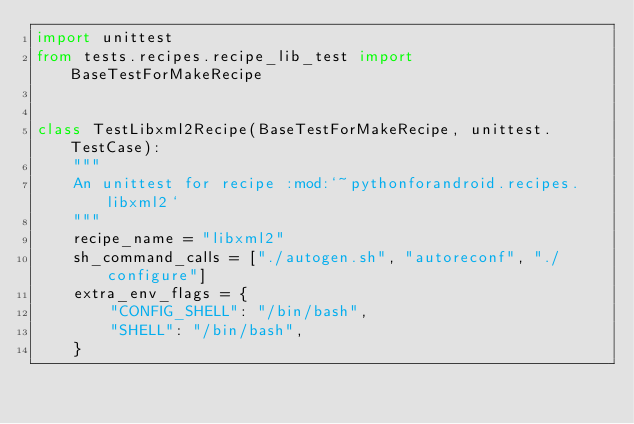<code> <loc_0><loc_0><loc_500><loc_500><_Python_>import unittest
from tests.recipes.recipe_lib_test import BaseTestForMakeRecipe


class TestLibxml2Recipe(BaseTestForMakeRecipe, unittest.TestCase):
    """
    An unittest for recipe :mod:`~pythonforandroid.recipes.libxml2`
    """
    recipe_name = "libxml2"
    sh_command_calls = ["./autogen.sh", "autoreconf", "./configure"]
    extra_env_flags = {
        "CONFIG_SHELL": "/bin/bash",
        "SHELL": "/bin/bash",
    }
</code> 